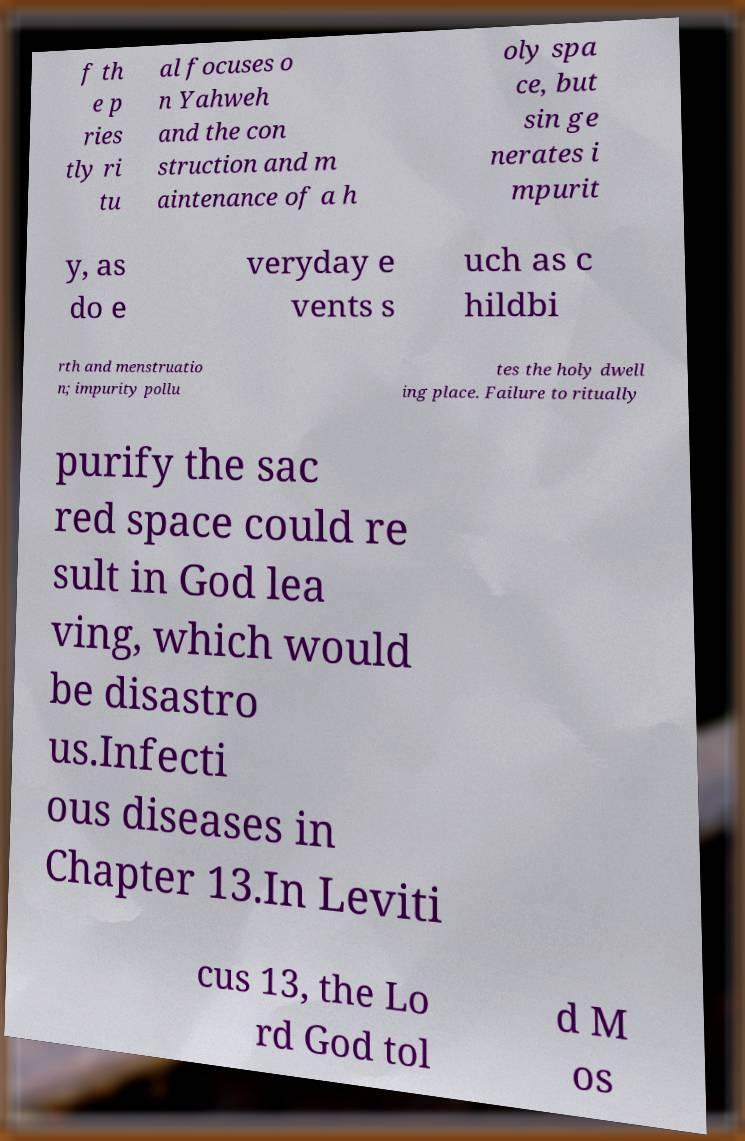What messages or text are displayed in this image? I need them in a readable, typed format. f th e p ries tly ri tu al focuses o n Yahweh and the con struction and m aintenance of a h oly spa ce, but sin ge nerates i mpurit y, as do e veryday e vents s uch as c hildbi rth and menstruatio n; impurity pollu tes the holy dwell ing place. Failure to ritually purify the sac red space could re sult in God lea ving, which would be disastro us.Infecti ous diseases in Chapter 13.In Leviti cus 13, the Lo rd God tol d M os 